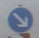Could you suggest any technological solutions or tools that could assist drivers or traffic analysts in these types of situations where visibility of traffic signs is compromised? Advanced Driver-Assistance Systems (ADAS) or augmented reality (AR) dashboards could be extremely beneficial in these circumstances. These technological tools could recognize hard-to-see signs and project this information onto a vehicle's display, enhancing driver awareness. Additionally, developing smarter AI-driven traffic sign recognition that integrates with real-time vehicle systems could promptly alert drivers to unrecognized or obscured signs based on GPS and known road information. 